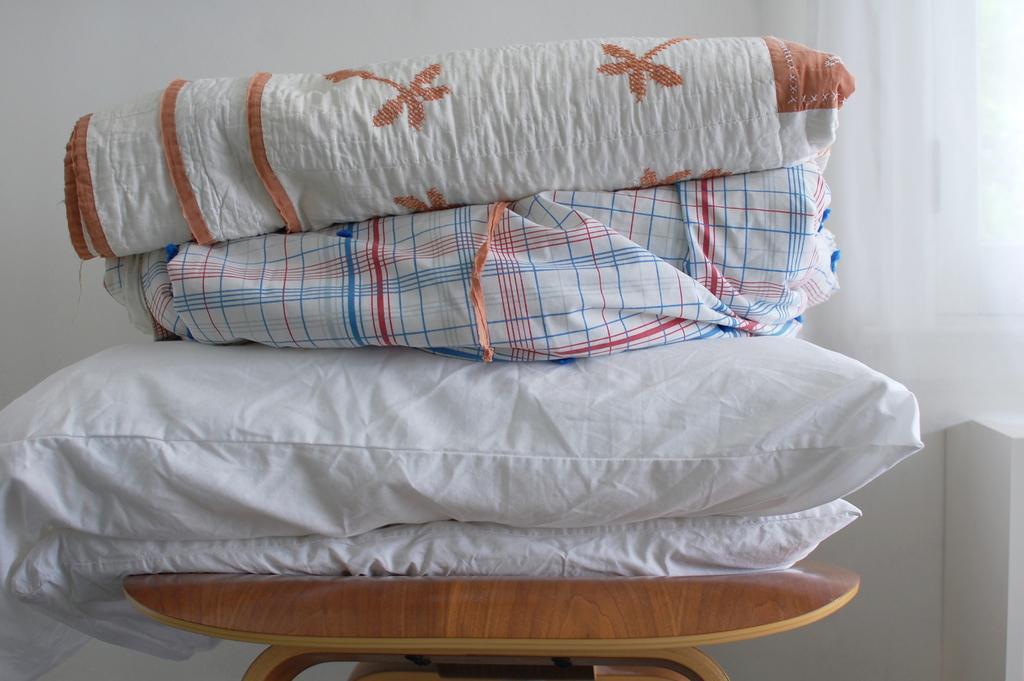How would you summarize this image in a sentence or two? In this image there are a few pillows and blankets placed on top of a table. 